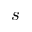<formula> <loc_0><loc_0><loc_500><loc_500>s</formula> 